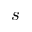<formula> <loc_0><loc_0><loc_500><loc_500>s</formula> 